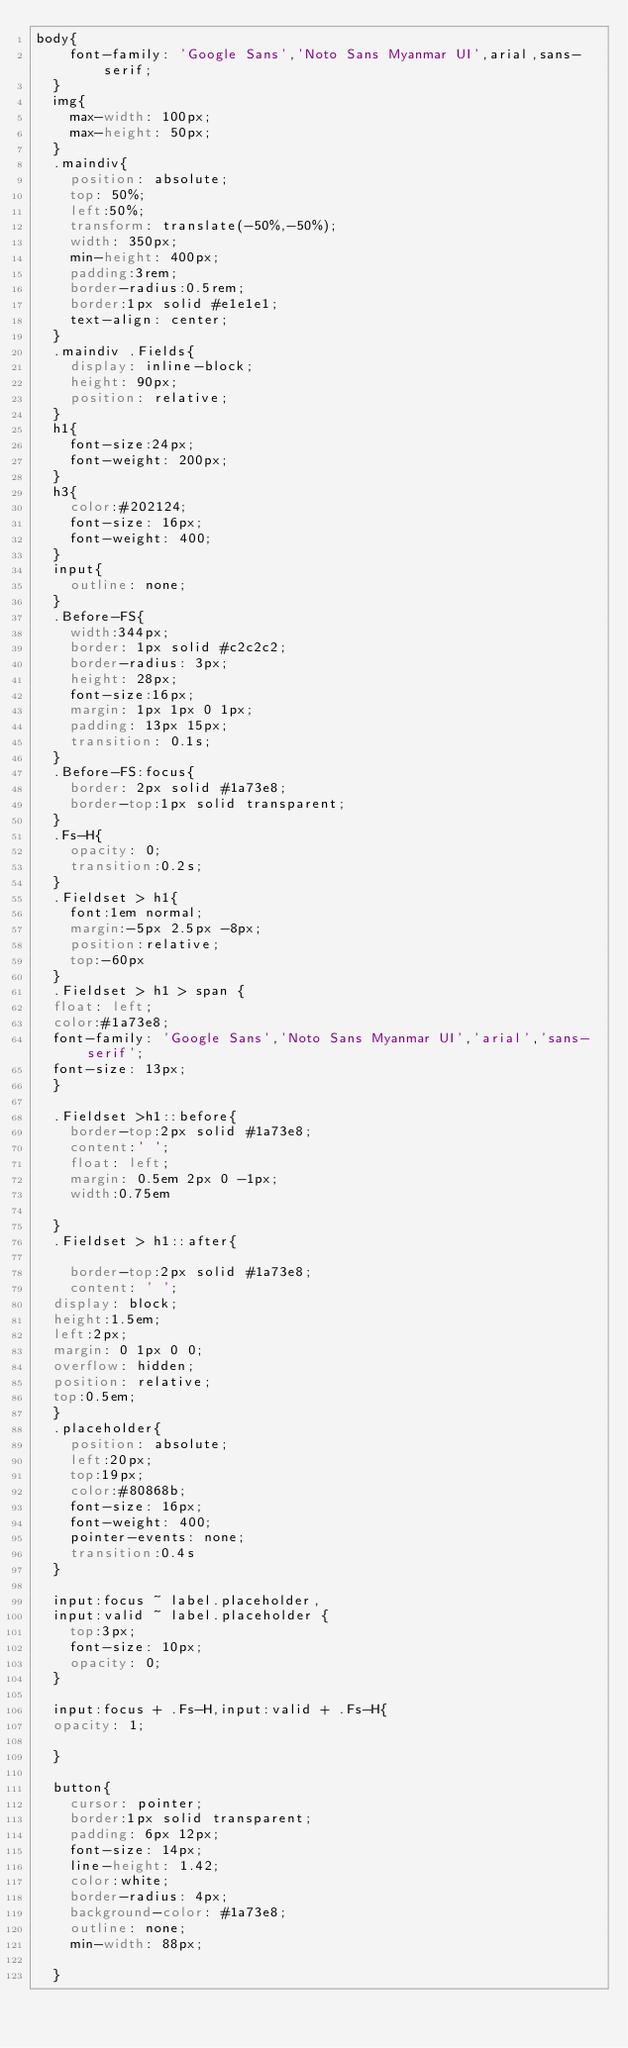Convert code to text. <code><loc_0><loc_0><loc_500><loc_500><_CSS_>body{
    font-family: 'Google Sans','Noto Sans Myanmar UI',arial,sans-serif;
  }
  img{
    max-width: 100px;
    max-height: 50px;
  }
  .maindiv{
    position: absolute;
    top: 50%;
    left:50%;
    transform: translate(-50%,-50%);
    width: 350px;
    min-height: 400px;
    padding:3rem;
    border-radius:0.5rem;
    border:1px solid #e1e1e1;
    text-align: center;
  }
  .maindiv .Fields{
    display: inline-block;
    height: 90px;
    position: relative;
  }
  h1{
    font-size:24px;
    font-weight: 200px;
  }
  h3{
    color:#202124;
    font-size: 16px;
    font-weight: 400;
  }
  input{
    outline: none;
  }
  .Before-FS{
    width:344px;
    border: 1px solid #c2c2c2;
    border-radius: 3px;
    height: 28px;
    font-size:16px;
    margin: 1px 1px 0 1px;
    padding: 13px 15px;
    transition: 0.1s;
  }
  .Before-FS:focus{
    border: 2px solid #1a73e8;
    border-top:1px solid transparent;
  }
  .Fs-H{
    opacity: 0;
    transition:0.2s;
  }
  .Fieldset > h1{
    font:1em normal;
    margin:-5px 2.5px -8px;
    position:relative;
    top:-60px
  }
  .Fieldset > h1 > span {
  float: left;
  color:#1a73e8;
  font-family: 'Google Sans','Noto Sans Myanmar UI','arial','sans-serif';
  font-size: 13px;
  }
  
  .Fieldset >h1::before{
    border-top:2px solid #1a73e8;
    content:' ';
    float: left;
    margin: 0.5em 2px 0 -1px;
    width:0.75em
  
  }
  .Fieldset > h1::after{
  
    border-top:2px solid #1a73e8;
    content: ' ';
  display: block;
  height:1.5em;
  left:2px;
  margin: 0 1px 0 0;
  overflow: hidden;
  position: relative;
  top:0.5em;
  }
  .placeholder{
    position: absolute;
    left:20px;
    top:19px;
    color:#80868b;
    font-size: 16px;
    font-weight: 400;
    pointer-events: none;
    transition:0.4s
  }
  
  input:focus ~ label.placeholder,
  input:valid ~ label.placeholder {
    top:3px;
    font-size: 10px;
    opacity: 0;
  }
  
  input:focus + .Fs-H,input:valid + .Fs-H{
  opacity: 1;
  
  }
  
  button{
    cursor: pointer;
    border:1px solid transparent;
    padding: 6px 12px;
    font-size: 14px;
    line-height: 1.42;
    color:white;
    border-radius: 4px;
    background-color: #1a73e8;
    outline: none;
    min-width: 88px;
  
  }</code> 